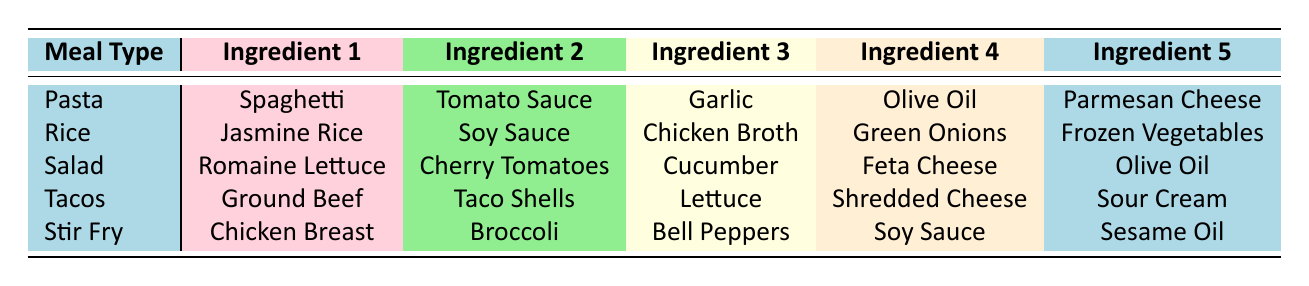What are the ingredients typically used in salad? Referring to the table, the meal type "Salad" lists five ingredients: Romaine Lettuce, Cherry Tomatoes, Cucumber, Feta Cheese, and Olive Oil.
Answer: Romaine Lettuce, Cherry Tomatoes, Cucumber, Feta Cheese, Olive Oil Does Pasta include Olive Oil as an ingredient? The table shows that for the meal type "Pasta," one of the ingredients is indeed Olive Oil.
Answer: Yes How many ingredients are listed for Tacos? The table indicates that the meal type "Tacos" has five ingredients listed, namely: Ground Beef, Taco Shells, Lettuce, Shredded Cheese, and Sour Cream.
Answer: 5 Which meal type has Ground Beef as an ingredient? The table specifies that Ground Beef is an ingredient for Tacos, so the meal type associated with this ingredient is Tacos.
Answer: Tacos Which meal type includes Soy Sauce? There are two meal types that include Soy Sauce: Rice and Stir Fry. This information can be pulled directly from the respective ingredient lists.
Answer: Rice, Stir Fry If I were to sum the total number of unique ingredients across all meal types, what would it be? The table lists a total of 5 ingredients for each of the 5 meal types, making 25 entries. However, some ingredients overlap, such as Olive Oil and Soy Sauce. Analyzing the unique ingredients results in 22: Spaghetti, Tomato Sauce, Garlic, Olive Oil, Parmesan Cheese, Jasmine Rice, Soy Sauce, Chicken Broth, Green Onions, Frozen Vegetables, Romaine Lettuce, Cherry Tomatoes, Cucumber, Feta Cheese, Ground Beef, Taco Shells, Lettuce, Shredded Cheese, Sour Cream, Chicken Breast, Broccoli, Bell Peppers, Sesame Oil.
Answer: 22 Is there an ingredient common to both Salad and Pasta? By examining the ingredient lists, Olive Oil appears in both the Salad and Pasta meal types, confirming it's common to both.
Answer: Yes What is the unique ingredient in Stir Fry that is not found in any other meal type? Analyzing the table, Chicken Breast, Broccoli, and Bell Peppers are ingredients that do not appear in any other meal types. Thus, they are all unique to Stir Fry, but Chicken Breast is specifically recognizable as the protein component that stands out.
Answer: Chicken Breast Which meal type uses Chicken Broth? The table shows that Chicken Broth is listed as an ingredient under the meal type "Rice."
Answer: Rice 